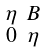Convert formula to latex. <formula><loc_0><loc_0><loc_500><loc_500>\begin{smallmatrix} \eta & B \\ 0 & \eta \end{smallmatrix}</formula> 